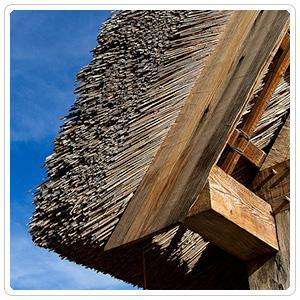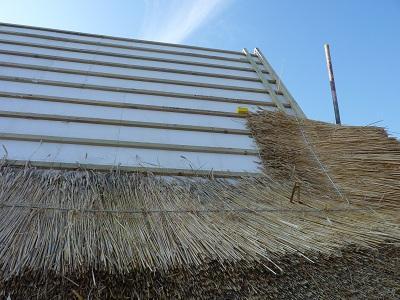The first image is the image on the left, the second image is the image on the right. For the images displayed, is the sentence "An image shows real thatch applied to a flat sloped roof, with something resembling ladder rungs on the right side." factually correct? Answer yes or no. Yes. The first image is the image on the left, the second image is the image on the right. Examine the images to the left and right. Is the description "The left image is just of a sample of hatch, no parts of a house can be seen." accurate? Answer yes or no. No. 